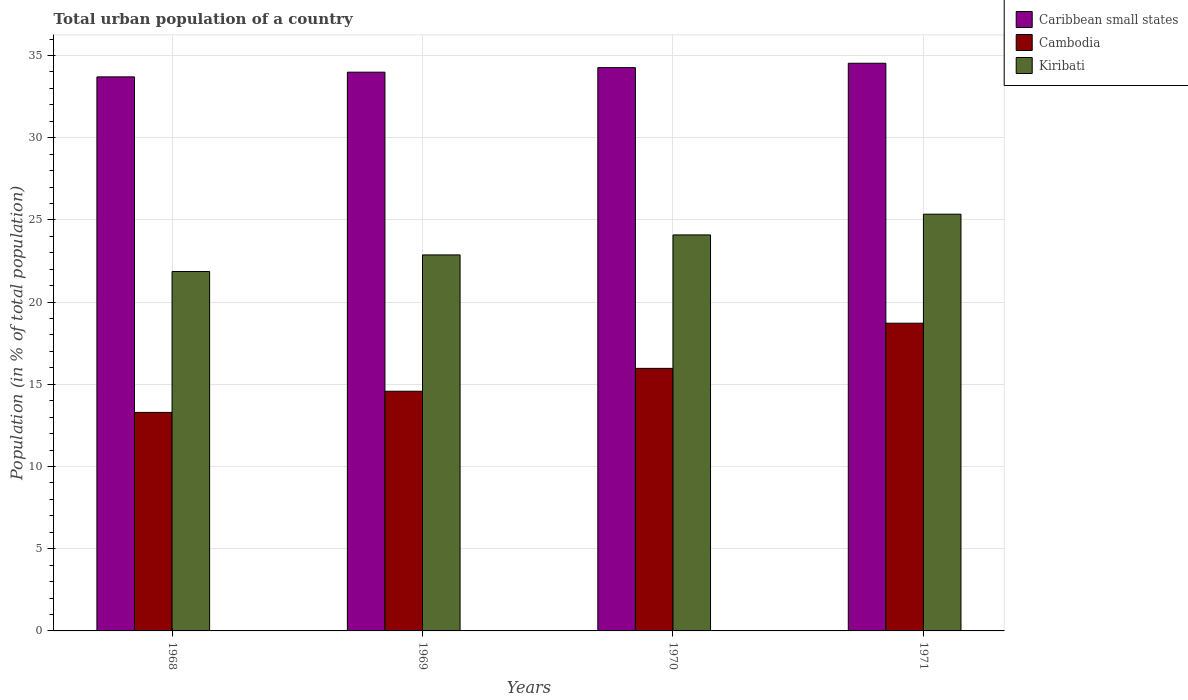How many different coloured bars are there?
Keep it short and to the point. 3. Are the number of bars per tick equal to the number of legend labels?
Your answer should be compact. Yes. How many bars are there on the 4th tick from the left?
Give a very brief answer. 3. What is the urban population in Kiribati in 1969?
Ensure brevity in your answer.  22.87. Across all years, what is the maximum urban population in Cambodia?
Provide a succinct answer. 18.72. Across all years, what is the minimum urban population in Kiribati?
Ensure brevity in your answer.  21.86. In which year was the urban population in Kiribati minimum?
Your answer should be compact. 1968. What is the total urban population in Cambodia in the graph?
Offer a very short reply. 62.56. What is the difference between the urban population in Caribbean small states in 1968 and that in 1971?
Make the answer very short. -0.83. What is the difference between the urban population in Kiribati in 1969 and the urban population in Cambodia in 1970?
Make the answer very short. 6.9. What is the average urban population in Cambodia per year?
Ensure brevity in your answer.  15.64. In the year 1968, what is the difference between the urban population in Cambodia and urban population in Kiribati?
Provide a succinct answer. -8.57. What is the ratio of the urban population in Kiribati in 1969 to that in 1970?
Your answer should be compact. 0.95. What is the difference between the highest and the second highest urban population in Kiribati?
Your answer should be compact. 1.26. What is the difference between the highest and the lowest urban population in Cambodia?
Ensure brevity in your answer.  5.43. Is the sum of the urban population in Cambodia in 1968 and 1970 greater than the maximum urban population in Caribbean small states across all years?
Ensure brevity in your answer.  No. What does the 2nd bar from the left in 1968 represents?
Make the answer very short. Cambodia. What does the 3rd bar from the right in 1968 represents?
Your answer should be compact. Caribbean small states. Are all the bars in the graph horizontal?
Offer a very short reply. No. How many years are there in the graph?
Provide a short and direct response. 4. Are the values on the major ticks of Y-axis written in scientific E-notation?
Provide a short and direct response. No. Where does the legend appear in the graph?
Provide a short and direct response. Top right. What is the title of the graph?
Offer a terse response. Total urban population of a country. Does "Liechtenstein" appear as one of the legend labels in the graph?
Your response must be concise. No. What is the label or title of the X-axis?
Offer a very short reply. Years. What is the label or title of the Y-axis?
Give a very brief answer. Population (in % of total population). What is the Population (in % of total population) in Caribbean small states in 1968?
Ensure brevity in your answer.  33.7. What is the Population (in % of total population) in Cambodia in 1968?
Provide a short and direct response. 13.29. What is the Population (in % of total population) in Kiribati in 1968?
Offer a terse response. 21.86. What is the Population (in % of total population) of Caribbean small states in 1969?
Keep it short and to the point. 33.99. What is the Population (in % of total population) of Cambodia in 1969?
Provide a short and direct response. 14.58. What is the Population (in % of total population) of Kiribati in 1969?
Offer a terse response. 22.87. What is the Population (in % of total population) of Caribbean small states in 1970?
Keep it short and to the point. 34.26. What is the Population (in % of total population) in Cambodia in 1970?
Offer a terse response. 15.97. What is the Population (in % of total population) in Kiribati in 1970?
Give a very brief answer. 24.09. What is the Population (in % of total population) in Caribbean small states in 1971?
Offer a very short reply. 34.53. What is the Population (in % of total population) of Cambodia in 1971?
Offer a very short reply. 18.72. What is the Population (in % of total population) in Kiribati in 1971?
Give a very brief answer. 25.35. Across all years, what is the maximum Population (in % of total population) of Caribbean small states?
Your answer should be compact. 34.53. Across all years, what is the maximum Population (in % of total population) in Cambodia?
Offer a terse response. 18.72. Across all years, what is the maximum Population (in % of total population) in Kiribati?
Offer a terse response. 25.35. Across all years, what is the minimum Population (in % of total population) of Caribbean small states?
Give a very brief answer. 33.7. Across all years, what is the minimum Population (in % of total population) of Cambodia?
Keep it short and to the point. 13.29. Across all years, what is the minimum Population (in % of total population) of Kiribati?
Your answer should be compact. 21.86. What is the total Population (in % of total population) in Caribbean small states in the graph?
Keep it short and to the point. 136.48. What is the total Population (in % of total population) of Cambodia in the graph?
Give a very brief answer. 62.56. What is the total Population (in % of total population) in Kiribati in the graph?
Provide a succinct answer. 94.17. What is the difference between the Population (in % of total population) in Caribbean small states in 1968 and that in 1969?
Provide a short and direct response. -0.29. What is the difference between the Population (in % of total population) of Cambodia in 1968 and that in 1969?
Give a very brief answer. -1.29. What is the difference between the Population (in % of total population) in Kiribati in 1968 and that in 1969?
Provide a succinct answer. -1.01. What is the difference between the Population (in % of total population) of Caribbean small states in 1968 and that in 1970?
Your answer should be very brief. -0.56. What is the difference between the Population (in % of total population) in Cambodia in 1968 and that in 1970?
Provide a short and direct response. -2.68. What is the difference between the Population (in % of total population) in Kiribati in 1968 and that in 1970?
Ensure brevity in your answer.  -2.23. What is the difference between the Population (in % of total population) in Caribbean small states in 1968 and that in 1971?
Make the answer very short. -0.83. What is the difference between the Population (in % of total population) in Cambodia in 1968 and that in 1971?
Keep it short and to the point. -5.43. What is the difference between the Population (in % of total population) of Kiribati in 1968 and that in 1971?
Provide a succinct answer. -3.48. What is the difference between the Population (in % of total population) of Caribbean small states in 1969 and that in 1970?
Provide a short and direct response. -0.28. What is the difference between the Population (in % of total population) in Cambodia in 1969 and that in 1970?
Ensure brevity in your answer.  -1.39. What is the difference between the Population (in % of total population) of Kiribati in 1969 and that in 1970?
Your response must be concise. -1.22. What is the difference between the Population (in % of total population) of Caribbean small states in 1969 and that in 1971?
Your answer should be compact. -0.54. What is the difference between the Population (in % of total population) in Cambodia in 1969 and that in 1971?
Offer a terse response. -4.14. What is the difference between the Population (in % of total population) of Kiribati in 1969 and that in 1971?
Offer a terse response. -2.48. What is the difference between the Population (in % of total population) of Caribbean small states in 1970 and that in 1971?
Give a very brief answer. -0.27. What is the difference between the Population (in % of total population) in Cambodia in 1970 and that in 1971?
Offer a terse response. -2.75. What is the difference between the Population (in % of total population) in Kiribati in 1970 and that in 1971?
Offer a terse response. -1.26. What is the difference between the Population (in % of total population) of Caribbean small states in 1968 and the Population (in % of total population) of Cambodia in 1969?
Your answer should be compact. 19.12. What is the difference between the Population (in % of total population) of Caribbean small states in 1968 and the Population (in % of total population) of Kiribati in 1969?
Your answer should be compact. 10.83. What is the difference between the Population (in % of total population) in Cambodia in 1968 and the Population (in % of total population) in Kiribati in 1969?
Your response must be concise. -9.58. What is the difference between the Population (in % of total population) in Caribbean small states in 1968 and the Population (in % of total population) in Cambodia in 1970?
Provide a short and direct response. 17.73. What is the difference between the Population (in % of total population) in Caribbean small states in 1968 and the Population (in % of total population) in Kiribati in 1970?
Offer a very short reply. 9.61. What is the difference between the Population (in % of total population) in Cambodia in 1968 and the Population (in % of total population) in Kiribati in 1970?
Offer a terse response. -10.8. What is the difference between the Population (in % of total population) of Caribbean small states in 1968 and the Population (in % of total population) of Cambodia in 1971?
Offer a very short reply. 14.98. What is the difference between the Population (in % of total population) of Caribbean small states in 1968 and the Population (in % of total population) of Kiribati in 1971?
Offer a very short reply. 8.35. What is the difference between the Population (in % of total population) of Cambodia in 1968 and the Population (in % of total population) of Kiribati in 1971?
Your answer should be compact. -12.06. What is the difference between the Population (in % of total population) of Caribbean small states in 1969 and the Population (in % of total population) of Cambodia in 1970?
Give a very brief answer. 18.02. What is the difference between the Population (in % of total population) in Caribbean small states in 1969 and the Population (in % of total population) in Kiribati in 1970?
Offer a very short reply. 9.9. What is the difference between the Population (in % of total population) of Cambodia in 1969 and the Population (in % of total population) of Kiribati in 1970?
Offer a very short reply. -9.51. What is the difference between the Population (in % of total population) of Caribbean small states in 1969 and the Population (in % of total population) of Cambodia in 1971?
Ensure brevity in your answer.  15.27. What is the difference between the Population (in % of total population) in Caribbean small states in 1969 and the Population (in % of total population) in Kiribati in 1971?
Your answer should be compact. 8.64. What is the difference between the Population (in % of total population) in Cambodia in 1969 and the Population (in % of total population) in Kiribati in 1971?
Provide a short and direct response. -10.77. What is the difference between the Population (in % of total population) in Caribbean small states in 1970 and the Population (in % of total population) in Cambodia in 1971?
Keep it short and to the point. 15.55. What is the difference between the Population (in % of total population) in Caribbean small states in 1970 and the Population (in % of total population) in Kiribati in 1971?
Your answer should be very brief. 8.92. What is the difference between the Population (in % of total population) of Cambodia in 1970 and the Population (in % of total population) of Kiribati in 1971?
Keep it short and to the point. -9.38. What is the average Population (in % of total population) in Caribbean small states per year?
Offer a very short reply. 34.12. What is the average Population (in % of total population) of Cambodia per year?
Offer a very short reply. 15.64. What is the average Population (in % of total population) of Kiribati per year?
Keep it short and to the point. 23.54. In the year 1968, what is the difference between the Population (in % of total population) in Caribbean small states and Population (in % of total population) in Cambodia?
Your answer should be very brief. 20.41. In the year 1968, what is the difference between the Population (in % of total population) of Caribbean small states and Population (in % of total population) of Kiribati?
Keep it short and to the point. 11.84. In the year 1968, what is the difference between the Population (in % of total population) of Cambodia and Population (in % of total population) of Kiribati?
Offer a very short reply. -8.57. In the year 1969, what is the difference between the Population (in % of total population) in Caribbean small states and Population (in % of total population) in Cambodia?
Your answer should be very brief. 19.41. In the year 1969, what is the difference between the Population (in % of total population) of Caribbean small states and Population (in % of total population) of Kiribati?
Ensure brevity in your answer.  11.12. In the year 1969, what is the difference between the Population (in % of total population) of Cambodia and Population (in % of total population) of Kiribati?
Make the answer very short. -8.29. In the year 1970, what is the difference between the Population (in % of total population) of Caribbean small states and Population (in % of total population) of Cambodia?
Provide a succinct answer. 18.29. In the year 1970, what is the difference between the Population (in % of total population) in Caribbean small states and Population (in % of total population) in Kiribati?
Provide a short and direct response. 10.18. In the year 1970, what is the difference between the Population (in % of total population) of Cambodia and Population (in % of total population) of Kiribati?
Your response must be concise. -8.12. In the year 1971, what is the difference between the Population (in % of total population) in Caribbean small states and Population (in % of total population) in Cambodia?
Ensure brevity in your answer.  15.81. In the year 1971, what is the difference between the Population (in % of total population) of Caribbean small states and Population (in % of total population) of Kiribati?
Give a very brief answer. 9.18. In the year 1971, what is the difference between the Population (in % of total population) in Cambodia and Population (in % of total population) in Kiribati?
Ensure brevity in your answer.  -6.63. What is the ratio of the Population (in % of total population) in Caribbean small states in 1968 to that in 1969?
Offer a very short reply. 0.99. What is the ratio of the Population (in % of total population) in Cambodia in 1968 to that in 1969?
Offer a terse response. 0.91. What is the ratio of the Population (in % of total population) of Kiribati in 1968 to that in 1969?
Your answer should be very brief. 0.96. What is the ratio of the Population (in % of total population) in Caribbean small states in 1968 to that in 1970?
Keep it short and to the point. 0.98. What is the ratio of the Population (in % of total population) of Cambodia in 1968 to that in 1970?
Give a very brief answer. 0.83. What is the ratio of the Population (in % of total population) in Kiribati in 1968 to that in 1970?
Your answer should be very brief. 0.91. What is the ratio of the Population (in % of total population) of Cambodia in 1968 to that in 1971?
Ensure brevity in your answer.  0.71. What is the ratio of the Population (in % of total population) in Kiribati in 1968 to that in 1971?
Your response must be concise. 0.86. What is the ratio of the Population (in % of total population) in Cambodia in 1969 to that in 1970?
Ensure brevity in your answer.  0.91. What is the ratio of the Population (in % of total population) in Kiribati in 1969 to that in 1970?
Offer a terse response. 0.95. What is the ratio of the Population (in % of total population) in Caribbean small states in 1969 to that in 1971?
Provide a short and direct response. 0.98. What is the ratio of the Population (in % of total population) in Cambodia in 1969 to that in 1971?
Your answer should be compact. 0.78. What is the ratio of the Population (in % of total population) of Kiribati in 1969 to that in 1971?
Make the answer very short. 0.9. What is the ratio of the Population (in % of total population) of Caribbean small states in 1970 to that in 1971?
Ensure brevity in your answer.  0.99. What is the ratio of the Population (in % of total population) of Cambodia in 1970 to that in 1971?
Offer a terse response. 0.85. What is the ratio of the Population (in % of total population) in Kiribati in 1970 to that in 1971?
Your response must be concise. 0.95. What is the difference between the highest and the second highest Population (in % of total population) in Caribbean small states?
Provide a short and direct response. 0.27. What is the difference between the highest and the second highest Population (in % of total population) of Cambodia?
Provide a succinct answer. 2.75. What is the difference between the highest and the second highest Population (in % of total population) in Kiribati?
Your answer should be very brief. 1.26. What is the difference between the highest and the lowest Population (in % of total population) in Caribbean small states?
Give a very brief answer. 0.83. What is the difference between the highest and the lowest Population (in % of total population) of Cambodia?
Your answer should be very brief. 5.43. What is the difference between the highest and the lowest Population (in % of total population) in Kiribati?
Your response must be concise. 3.48. 